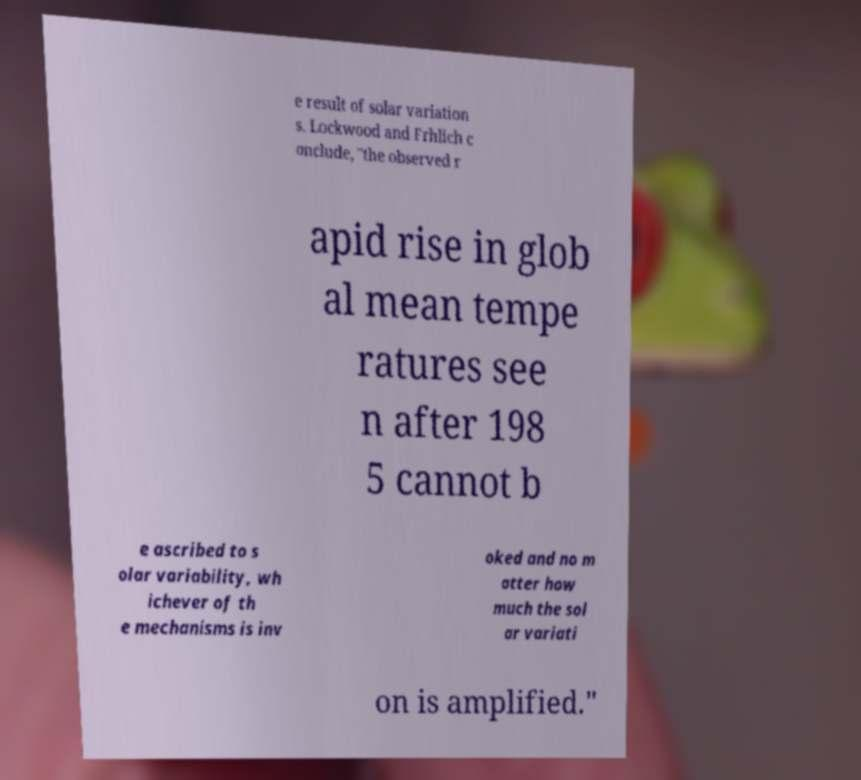There's text embedded in this image that I need extracted. Can you transcribe it verbatim? e result of solar variation s. Lockwood and Frhlich c onclude, "the observed r apid rise in glob al mean tempe ratures see n after 198 5 cannot b e ascribed to s olar variability, wh ichever of th e mechanisms is inv oked and no m atter how much the sol ar variati on is amplified." 